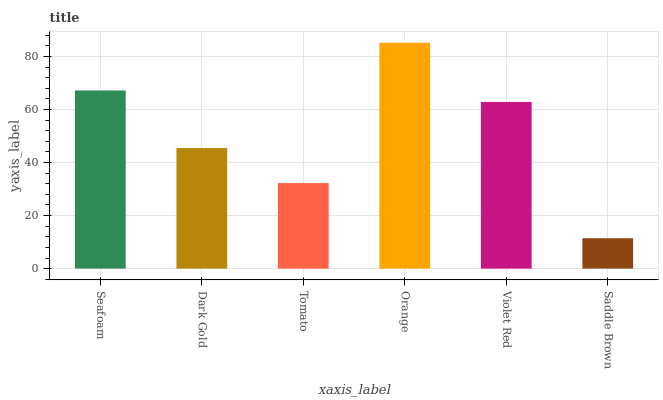Is Saddle Brown the minimum?
Answer yes or no. Yes. Is Orange the maximum?
Answer yes or no. Yes. Is Dark Gold the minimum?
Answer yes or no. No. Is Dark Gold the maximum?
Answer yes or no. No. Is Seafoam greater than Dark Gold?
Answer yes or no. Yes. Is Dark Gold less than Seafoam?
Answer yes or no. Yes. Is Dark Gold greater than Seafoam?
Answer yes or no. No. Is Seafoam less than Dark Gold?
Answer yes or no. No. Is Violet Red the high median?
Answer yes or no. Yes. Is Dark Gold the low median?
Answer yes or no. Yes. Is Saddle Brown the high median?
Answer yes or no. No. Is Orange the low median?
Answer yes or no. No. 